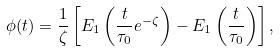Convert formula to latex. <formula><loc_0><loc_0><loc_500><loc_500>\phi ( t ) = \frac { 1 } { \zeta } \left [ E _ { 1 } \left ( \frac { t } { \tau _ { 0 } } e ^ { - \zeta } \right ) - E _ { 1 } \left ( \frac { t } { \tau _ { 0 } } \right ) \right ] ,</formula> 